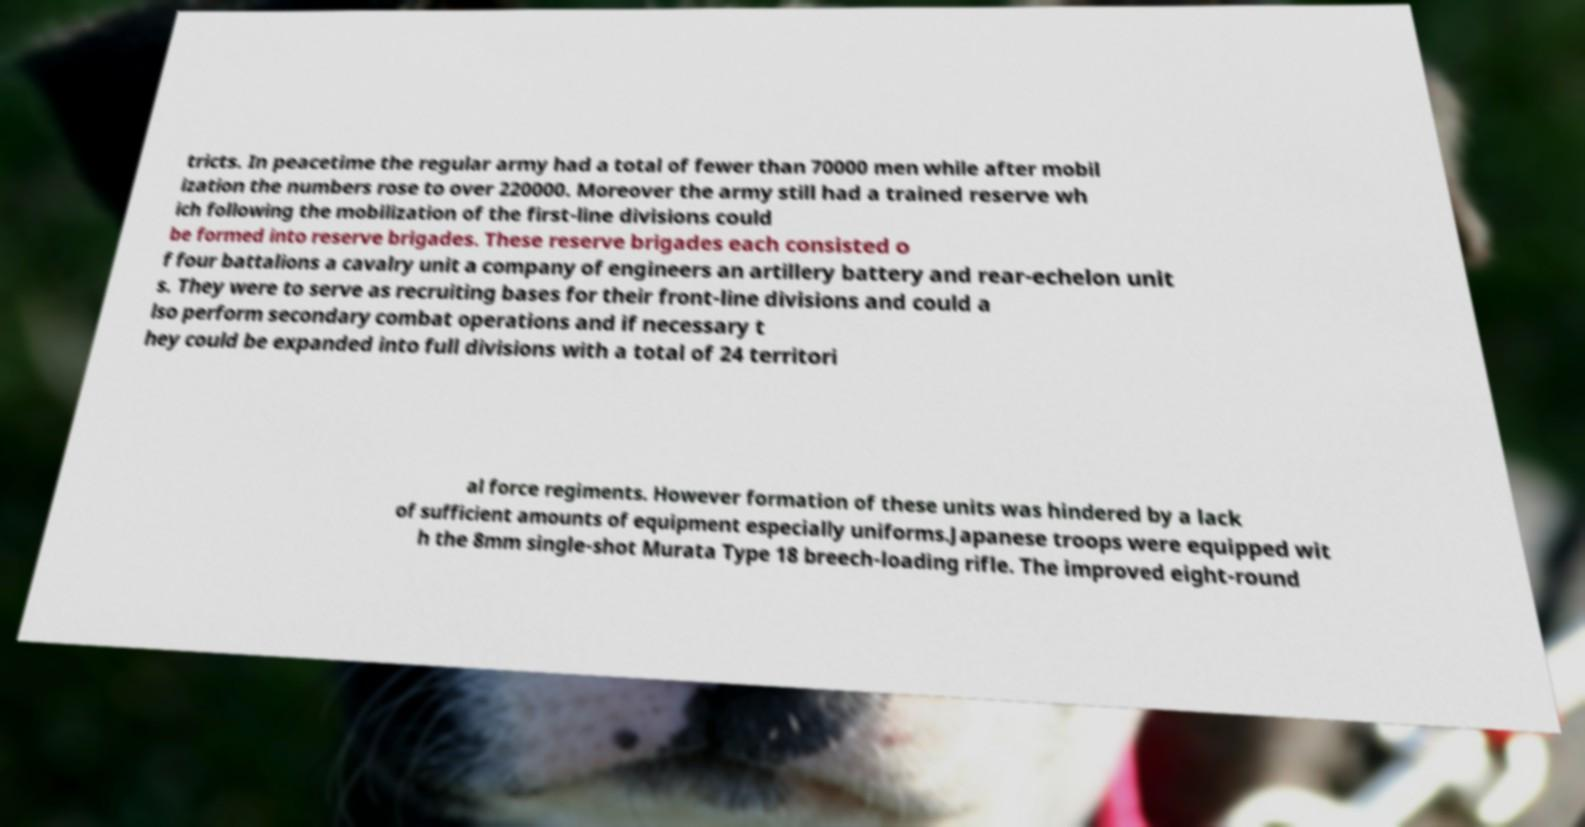Can you accurately transcribe the text from the provided image for me? tricts. In peacetime the regular army had a total of fewer than 70000 men while after mobil ization the numbers rose to over 220000. Moreover the army still had a trained reserve wh ich following the mobilization of the first-line divisions could be formed into reserve brigades. These reserve brigades each consisted o f four battalions a cavalry unit a company of engineers an artillery battery and rear-echelon unit s. They were to serve as recruiting bases for their front-line divisions and could a lso perform secondary combat operations and if necessary t hey could be expanded into full divisions with a total of 24 territori al force regiments. However formation of these units was hindered by a lack of sufficient amounts of equipment especially uniforms.Japanese troops were equipped wit h the 8mm single-shot Murata Type 18 breech-loading rifle. The improved eight-round 